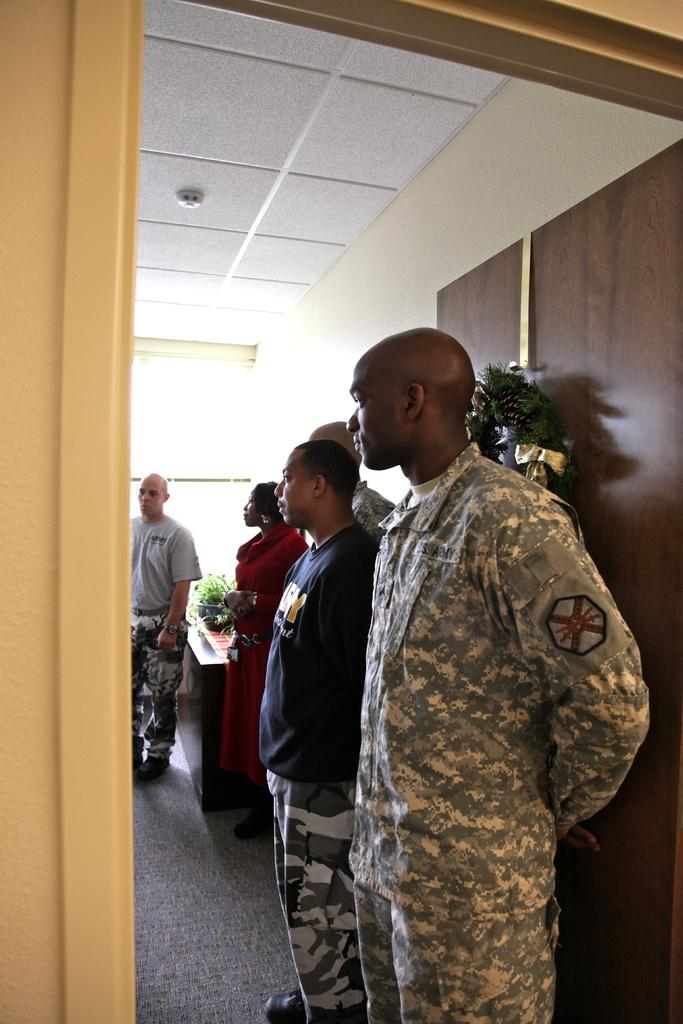How many people are standing in the image? There are few persons standing on the floor in the image. What is present on the floor besides the people? There is a carpet on the floor. What furniture can be seen in the image? There is a table in the image. What is the purpose of the door in the image? The door in the image provides access to another room or area. What decorative item is present in the image? There is a bouquet in the image. What type of background is visible in the image? There is a wall in the image. Is there a bomb visible in the image? No, there is no bomb present in the image. Can you tell me how many times the people in the image need to pull the door to open it? The image does not provide information about the number of times the door needs to be pulled to open it. 